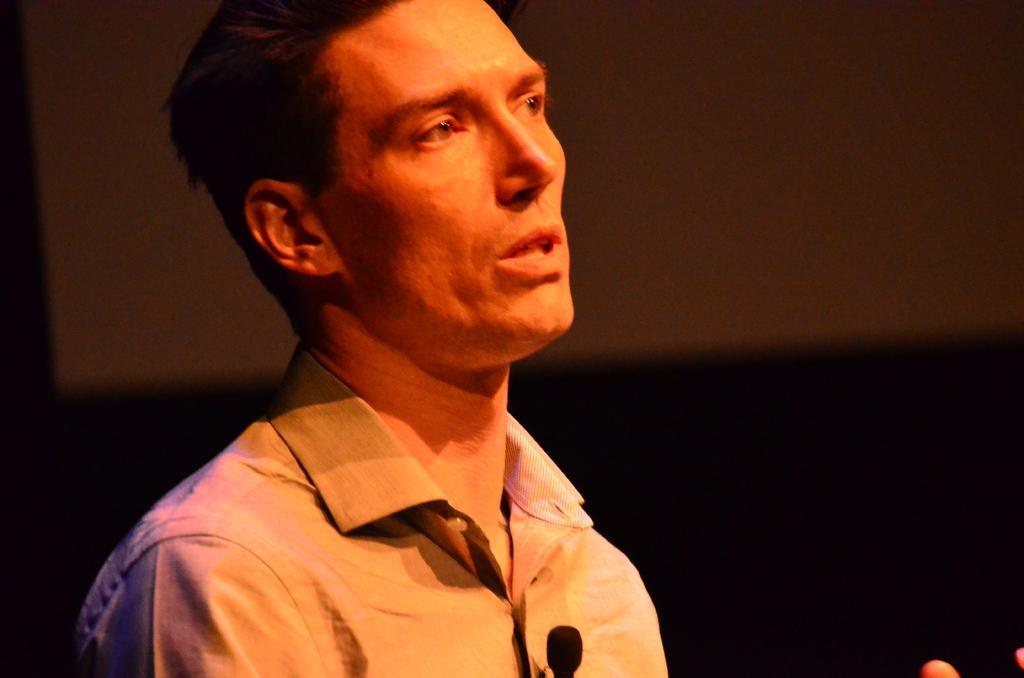Could you give a brief overview of what you see in this image? In the center of this picture we can see a person wearing shirt and seems to be standing. In the background we can see some other objects. 